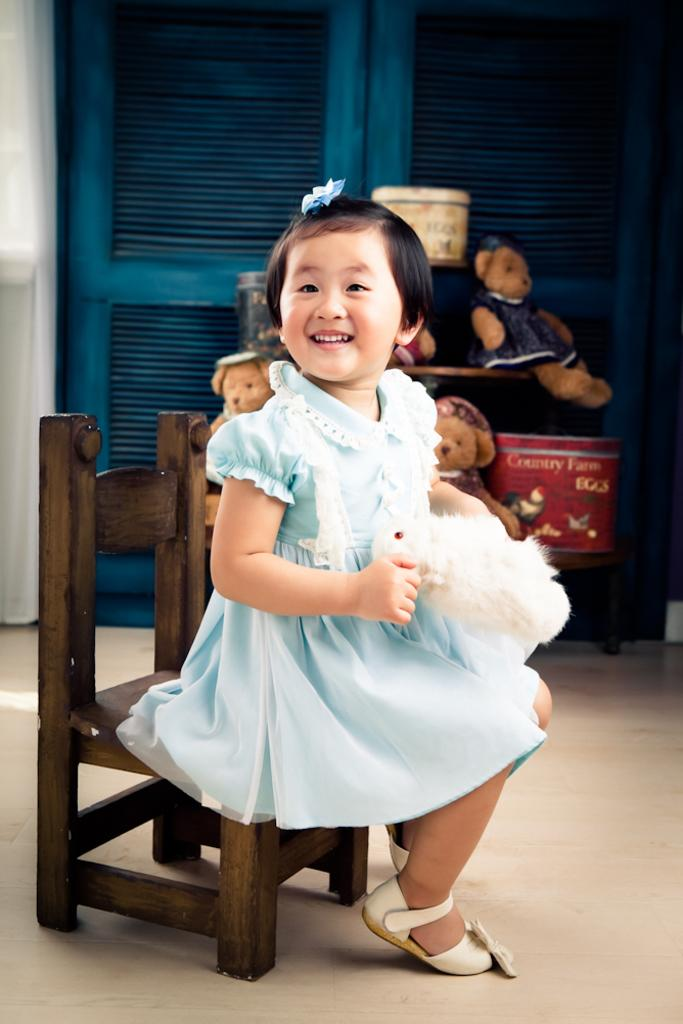Who is the main subject in the image? There is a girl in the image. What is the girl holding in the image? The girl is holding a soft toy. What is the girl's position in the image? The girl is sitting on a chair. What can be seen in the background of the image? There is a blue color door and soft toys in the background of the image. How many women are visible in the image? There is only one person visible in the image, and it is a girl. What type of spiders can be seen crawling on the soft toys in the image? There are no spiders present in the image; it only features a girl, a soft toy, and a blue color door in the background. 